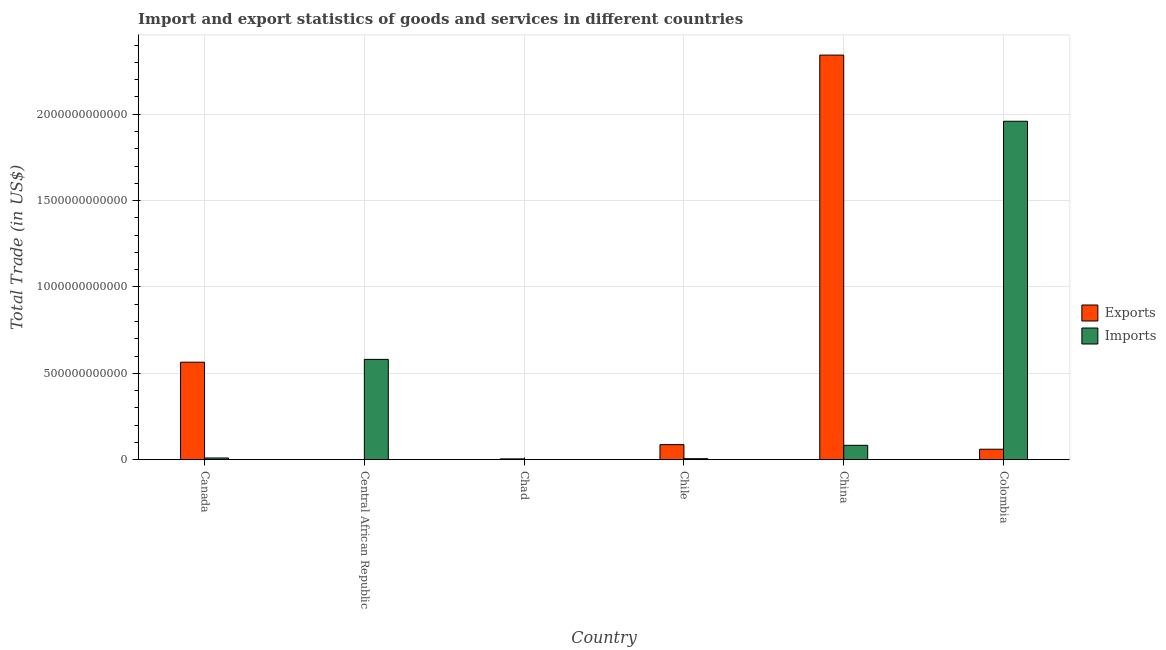Are the number of bars on each tick of the X-axis equal?
Ensure brevity in your answer.  Yes. How many bars are there on the 3rd tick from the left?
Provide a succinct answer. 2. How many bars are there on the 2nd tick from the right?
Your answer should be very brief. 2. What is the label of the 4th group of bars from the left?
Provide a succinct answer. Chile. In how many cases, is the number of bars for a given country not equal to the number of legend labels?
Your answer should be compact. 0. What is the export of goods and services in Canada?
Make the answer very short. 5.64e+11. Across all countries, what is the maximum imports of goods and services?
Your response must be concise. 1.96e+12. Across all countries, what is the minimum export of goods and services?
Keep it short and to the point. 2.12e+08. In which country was the export of goods and services maximum?
Make the answer very short. China. In which country was the imports of goods and services minimum?
Ensure brevity in your answer.  Chad. What is the total export of goods and services in the graph?
Make the answer very short. 3.06e+12. What is the difference between the imports of goods and services in Central African Republic and that in Colombia?
Give a very brief answer. -1.38e+12. What is the difference between the export of goods and services in Chad and the imports of goods and services in Chile?
Your response must be concise. -1.16e+09. What is the average imports of goods and services per country?
Offer a terse response. 4.40e+11. What is the difference between the imports of goods and services and export of goods and services in Central African Republic?
Keep it short and to the point. 5.80e+11. In how many countries, is the imports of goods and services greater than 400000000000 US$?
Give a very brief answer. 2. What is the ratio of the imports of goods and services in China to that in Colombia?
Make the answer very short. 0.04. Is the difference between the imports of goods and services in Central African Republic and Chad greater than the difference between the export of goods and services in Central African Republic and Chad?
Provide a succinct answer. Yes. What is the difference between the highest and the second highest export of goods and services?
Ensure brevity in your answer.  1.78e+12. What is the difference between the highest and the lowest imports of goods and services?
Your answer should be compact. 1.96e+12. In how many countries, is the export of goods and services greater than the average export of goods and services taken over all countries?
Give a very brief answer. 2. Is the sum of the imports of goods and services in Central African Republic and China greater than the maximum export of goods and services across all countries?
Offer a very short reply. No. What does the 2nd bar from the left in Central African Republic represents?
Make the answer very short. Imports. What does the 2nd bar from the right in Canada represents?
Keep it short and to the point. Exports. How many bars are there?
Provide a short and direct response. 12. What is the difference between two consecutive major ticks on the Y-axis?
Your answer should be very brief. 5.00e+11. Where does the legend appear in the graph?
Give a very brief answer. Center right. What is the title of the graph?
Ensure brevity in your answer.  Import and export statistics of goods and services in different countries. What is the label or title of the Y-axis?
Ensure brevity in your answer.  Total Trade (in US$). What is the Total Trade (in US$) of Exports in Canada?
Your answer should be very brief. 5.64e+11. What is the Total Trade (in US$) in Imports in Canada?
Your answer should be compact. 9.98e+09. What is the Total Trade (in US$) of Exports in Central African Republic?
Offer a very short reply. 2.12e+08. What is the Total Trade (in US$) in Imports in Central African Republic?
Your response must be concise. 5.81e+11. What is the Total Trade (in US$) of Exports in Chad?
Offer a terse response. 4.76e+09. What is the Total Trade (in US$) of Imports in Chad?
Keep it short and to the point. 6.40e+08. What is the Total Trade (in US$) of Exports in Chile?
Ensure brevity in your answer.  8.72e+1. What is the Total Trade (in US$) of Imports in Chile?
Keep it short and to the point. 5.91e+09. What is the Total Trade (in US$) of Exports in China?
Provide a succinct answer. 2.34e+12. What is the Total Trade (in US$) of Imports in China?
Your answer should be very brief. 8.33e+1. What is the Total Trade (in US$) of Exports in Colombia?
Make the answer very short. 6.06e+1. What is the Total Trade (in US$) in Imports in Colombia?
Give a very brief answer. 1.96e+12. Across all countries, what is the maximum Total Trade (in US$) of Exports?
Ensure brevity in your answer.  2.34e+12. Across all countries, what is the maximum Total Trade (in US$) of Imports?
Provide a short and direct response. 1.96e+12. Across all countries, what is the minimum Total Trade (in US$) in Exports?
Provide a short and direct response. 2.12e+08. Across all countries, what is the minimum Total Trade (in US$) in Imports?
Your answer should be compact. 6.40e+08. What is the total Total Trade (in US$) of Exports in the graph?
Offer a very short reply. 3.06e+12. What is the total Total Trade (in US$) in Imports in the graph?
Offer a very short reply. 2.64e+12. What is the difference between the Total Trade (in US$) in Exports in Canada and that in Central African Republic?
Your answer should be very brief. 5.64e+11. What is the difference between the Total Trade (in US$) in Imports in Canada and that in Central African Republic?
Your answer should be very brief. -5.71e+11. What is the difference between the Total Trade (in US$) of Exports in Canada and that in Chad?
Your response must be concise. 5.60e+11. What is the difference between the Total Trade (in US$) in Imports in Canada and that in Chad?
Your response must be concise. 9.34e+09. What is the difference between the Total Trade (in US$) of Exports in Canada and that in Chile?
Provide a short and direct response. 4.77e+11. What is the difference between the Total Trade (in US$) in Imports in Canada and that in Chile?
Give a very brief answer. 4.07e+09. What is the difference between the Total Trade (in US$) in Exports in Canada and that in China?
Offer a terse response. -1.78e+12. What is the difference between the Total Trade (in US$) in Imports in Canada and that in China?
Your answer should be compact. -7.34e+1. What is the difference between the Total Trade (in US$) of Exports in Canada and that in Colombia?
Make the answer very short. 5.04e+11. What is the difference between the Total Trade (in US$) of Imports in Canada and that in Colombia?
Offer a terse response. -1.95e+12. What is the difference between the Total Trade (in US$) in Exports in Central African Republic and that in Chad?
Offer a very short reply. -4.54e+09. What is the difference between the Total Trade (in US$) of Imports in Central African Republic and that in Chad?
Provide a succinct answer. 5.80e+11. What is the difference between the Total Trade (in US$) of Exports in Central African Republic and that in Chile?
Your answer should be compact. -8.70e+1. What is the difference between the Total Trade (in US$) of Imports in Central African Republic and that in Chile?
Your answer should be compact. 5.75e+11. What is the difference between the Total Trade (in US$) in Exports in Central African Republic and that in China?
Ensure brevity in your answer.  -2.34e+12. What is the difference between the Total Trade (in US$) of Imports in Central African Republic and that in China?
Make the answer very short. 4.97e+11. What is the difference between the Total Trade (in US$) of Exports in Central African Republic and that in Colombia?
Provide a short and direct response. -6.04e+1. What is the difference between the Total Trade (in US$) of Imports in Central African Republic and that in Colombia?
Give a very brief answer. -1.38e+12. What is the difference between the Total Trade (in US$) of Exports in Chad and that in Chile?
Make the answer very short. -8.24e+1. What is the difference between the Total Trade (in US$) of Imports in Chad and that in Chile?
Provide a short and direct response. -5.27e+09. What is the difference between the Total Trade (in US$) of Exports in Chad and that in China?
Offer a terse response. -2.34e+12. What is the difference between the Total Trade (in US$) in Imports in Chad and that in China?
Keep it short and to the point. -8.27e+1. What is the difference between the Total Trade (in US$) of Exports in Chad and that in Colombia?
Offer a very short reply. -5.58e+1. What is the difference between the Total Trade (in US$) of Imports in Chad and that in Colombia?
Make the answer very short. -1.96e+12. What is the difference between the Total Trade (in US$) in Exports in Chile and that in China?
Make the answer very short. -2.25e+12. What is the difference between the Total Trade (in US$) of Imports in Chile and that in China?
Provide a succinct answer. -7.74e+1. What is the difference between the Total Trade (in US$) of Exports in Chile and that in Colombia?
Offer a very short reply. 2.66e+1. What is the difference between the Total Trade (in US$) of Imports in Chile and that in Colombia?
Your answer should be compact. -1.95e+12. What is the difference between the Total Trade (in US$) of Exports in China and that in Colombia?
Give a very brief answer. 2.28e+12. What is the difference between the Total Trade (in US$) of Imports in China and that in Colombia?
Offer a very short reply. -1.88e+12. What is the difference between the Total Trade (in US$) of Exports in Canada and the Total Trade (in US$) of Imports in Central African Republic?
Provide a short and direct response. -1.63e+1. What is the difference between the Total Trade (in US$) of Exports in Canada and the Total Trade (in US$) of Imports in Chad?
Offer a terse response. 5.64e+11. What is the difference between the Total Trade (in US$) in Exports in Canada and the Total Trade (in US$) in Imports in Chile?
Your answer should be compact. 5.59e+11. What is the difference between the Total Trade (in US$) of Exports in Canada and the Total Trade (in US$) of Imports in China?
Your answer should be compact. 4.81e+11. What is the difference between the Total Trade (in US$) in Exports in Canada and the Total Trade (in US$) in Imports in Colombia?
Offer a very short reply. -1.39e+12. What is the difference between the Total Trade (in US$) in Exports in Central African Republic and the Total Trade (in US$) in Imports in Chad?
Give a very brief answer. -4.27e+08. What is the difference between the Total Trade (in US$) of Exports in Central African Republic and the Total Trade (in US$) of Imports in Chile?
Give a very brief answer. -5.70e+09. What is the difference between the Total Trade (in US$) in Exports in Central African Republic and the Total Trade (in US$) in Imports in China?
Ensure brevity in your answer.  -8.31e+1. What is the difference between the Total Trade (in US$) in Exports in Central African Republic and the Total Trade (in US$) in Imports in Colombia?
Keep it short and to the point. -1.96e+12. What is the difference between the Total Trade (in US$) of Exports in Chad and the Total Trade (in US$) of Imports in Chile?
Ensure brevity in your answer.  -1.16e+09. What is the difference between the Total Trade (in US$) in Exports in Chad and the Total Trade (in US$) in Imports in China?
Provide a succinct answer. -7.86e+1. What is the difference between the Total Trade (in US$) of Exports in Chad and the Total Trade (in US$) of Imports in Colombia?
Ensure brevity in your answer.  -1.95e+12. What is the difference between the Total Trade (in US$) of Exports in Chile and the Total Trade (in US$) of Imports in China?
Your response must be concise. 3.83e+09. What is the difference between the Total Trade (in US$) in Exports in Chile and the Total Trade (in US$) in Imports in Colombia?
Make the answer very short. -1.87e+12. What is the difference between the Total Trade (in US$) in Exports in China and the Total Trade (in US$) in Imports in Colombia?
Your answer should be compact. 3.83e+11. What is the average Total Trade (in US$) of Exports per country?
Give a very brief answer. 5.10e+11. What is the average Total Trade (in US$) in Imports per country?
Ensure brevity in your answer.  4.40e+11. What is the difference between the Total Trade (in US$) of Exports and Total Trade (in US$) of Imports in Canada?
Make the answer very short. 5.54e+11. What is the difference between the Total Trade (in US$) in Exports and Total Trade (in US$) in Imports in Central African Republic?
Offer a terse response. -5.80e+11. What is the difference between the Total Trade (in US$) of Exports and Total Trade (in US$) of Imports in Chad?
Ensure brevity in your answer.  4.12e+09. What is the difference between the Total Trade (in US$) in Exports and Total Trade (in US$) in Imports in Chile?
Your answer should be compact. 8.13e+1. What is the difference between the Total Trade (in US$) of Exports and Total Trade (in US$) of Imports in China?
Make the answer very short. 2.26e+12. What is the difference between the Total Trade (in US$) in Exports and Total Trade (in US$) in Imports in Colombia?
Keep it short and to the point. -1.90e+12. What is the ratio of the Total Trade (in US$) in Exports in Canada to that in Central African Republic?
Provide a succinct answer. 2657.39. What is the ratio of the Total Trade (in US$) in Imports in Canada to that in Central African Republic?
Offer a very short reply. 0.02. What is the ratio of the Total Trade (in US$) of Exports in Canada to that in Chad?
Your answer should be very brief. 118.68. What is the ratio of the Total Trade (in US$) of Imports in Canada to that in Chad?
Your answer should be compact. 15.61. What is the ratio of the Total Trade (in US$) of Exports in Canada to that in Chile?
Give a very brief answer. 6.48. What is the ratio of the Total Trade (in US$) in Imports in Canada to that in Chile?
Ensure brevity in your answer.  1.69. What is the ratio of the Total Trade (in US$) in Exports in Canada to that in China?
Your response must be concise. 0.24. What is the ratio of the Total Trade (in US$) in Imports in Canada to that in China?
Offer a terse response. 0.12. What is the ratio of the Total Trade (in US$) of Exports in Canada to that in Colombia?
Offer a terse response. 9.32. What is the ratio of the Total Trade (in US$) in Imports in Canada to that in Colombia?
Make the answer very short. 0.01. What is the ratio of the Total Trade (in US$) in Exports in Central African Republic to that in Chad?
Your answer should be compact. 0.04. What is the ratio of the Total Trade (in US$) of Imports in Central African Republic to that in Chad?
Your answer should be very brief. 907.83. What is the ratio of the Total Trade (in US$) of Exports in Central African Republic to that in Chile?
Provide a short and direct response. 0. What is the ratio of the Total Trade (in US$) in Imports in Central African Republic to that in Chile?
Keep it short and to the point. 98.22. What is the ratio of the Total Trade (in US$) of Exports in Central African Republic to that in China?
Your answer should be compact. 0. What is the ratio of the Total Trade (in US$) of Imports in Central African Republic to that in China?
Make the answer very short. 6.97. What is the ratio of the Total Trade (in US$) in Exports in Central African Republic to that in Colombia?
Keep it short and to the point. 0. What is the ratio of the Total Trade (in US$) in Imports in Central African Republic to that in Colombia?
Keep it short and to the point. 0.3. What is the ratio of the Total Trade (in US$) of Exports in Chad to that in Chile?
Your response must be concise. 0.05. What is the ratio of the Total Trade (in US$) in Imports in Chad to that in Chile?
Provide a short and direct response. 0.11. What is the ratio of the Total Trade (in US$) of Exports in Chad to that in China?
Give a very brief answer. 0. What is the ratio of the Total Trade (in US$) of Imports in Chad to that in China?
Make the answer very short. 0.01. What is the ratio of the Total Trade (in US$) in Exports in Chad to that in Colombia?
Offer a terse response. 0.08. What is the ratio of the Total Trade (in US$) of Exports in Chile to that in China?
Offer a terse response. 0.04. What is the ratio of the Total Trade (in US$) in Imports in Chile to that in China?
Your response must be concise. 0.07. What is the ratio of the Total Trade (in US$) of Exports in Chile to that in Colombia?
Provide a short and direct response. 1.44. What is the ratio of the Total Trade (in US$) of Imports in Chile to that in Colombia?
Make the answer very short. 0. What is the ratio of the Total Trade (in US$) in Exports in China to that in Colombia?
Your answer should be compact. 38.66. What is the ratio of the Total Trade (in US$) of Imports in China to that in Colombia?
Give a very brief answer. 0.04. What is the difference between the highest and the second highest Total Trade (in US$) in Exports?
Provide a short and direct response. 1.78e+12. What is the difference between the highest and the second highest Total Trade (in US$) of Imports?
Your response must be concise. 1.38e+12. What is the difference between the highest and the lowest Total Trade (in US$) in Exports?
Provide a succinct answer. 2.34e+12. What is the difference between the highest and the lowest Total Trade (in US$) in Imports?
Make the answer very short. 1.96e+12. 